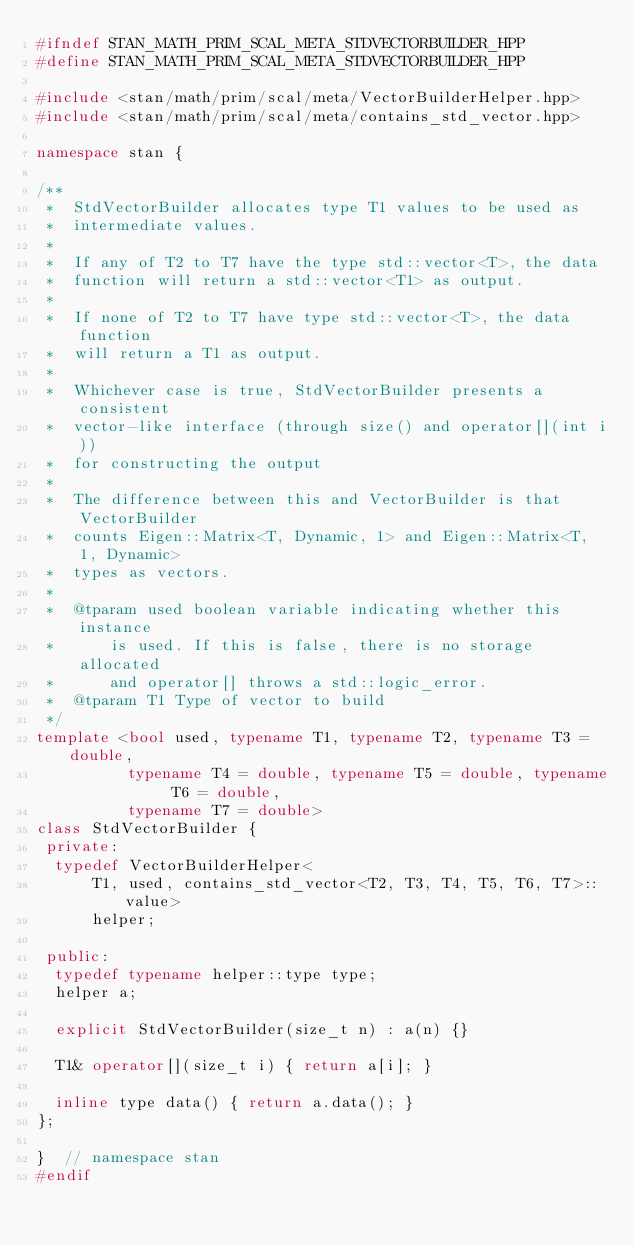Convert code to text. <code><loc_0><loc_0><loc_500><loc_500><_C++_>#ifndef STAN_MATH_PRIM_SCAL_META_STDVECTORBUILDER_HPP
#define STAN_MATH_PRIM_SCAL_META_STDVECTORBUILDER_HPP

#include <stan/math/prim/scal/meta/VectorBuilderHelper.hpp>
#include <stan/math/prim/scal/meta/contains_std_vector.hpp>

namespace stan {

/**
 *  StdVectorBuilder allocates type T1 values to be used as
 *  intermediate values.
 *
 *  If any of T2 to T7 have the type std::vector<T>, the data
 *  function will return a std::vector<T1> as output.
 *
 *  If none of T2 to T7 have type std::vector<T>, the data function
 *  will return a T1 as output.
 *
 *  Whichever case is true, StdVectorBuilder presents a consistent
 *  vector-like interface (through size() and operator[](int i))
 *  for constructing the output
 *
 *  The difference between this and VectorBuilder is that VectorBuilder
 *  counts Eigen::Matrix<T, Dynamic, 1> and Eigen::Matrix<T, 1, Dynamic>
 *  types as vectors.
 *
 *  @tparam used boolean variable indicating whether this instance
 *      is used. If this is false, there is no storage allocated
 *      and operator[] throws a std::logic_error.
 *  @tparam T1 Type of vector to build
 */
template <bool used, typename T1, typename T2, typename T3 = double,
          typename T4 = double, typename T5 = double, typename T6 = double,
          typename T7 = double>
class StdVectorBuilder {
 private:
  typedef VectorBuilderHelper<
      T1, used, contains_std_vector<T2, T3, T4, T5, T6, T7>::value>
      helper;

 public:
  typedef typename helper::type type;
  helper a;

  explicit StdVectorBuilder(size_t n) : a(n) {}

  T1& operator[](size_t i) { return a[i]; }

  inline type data() { return a.data(); }
};

}  // namespace stan
#endif
</code> 